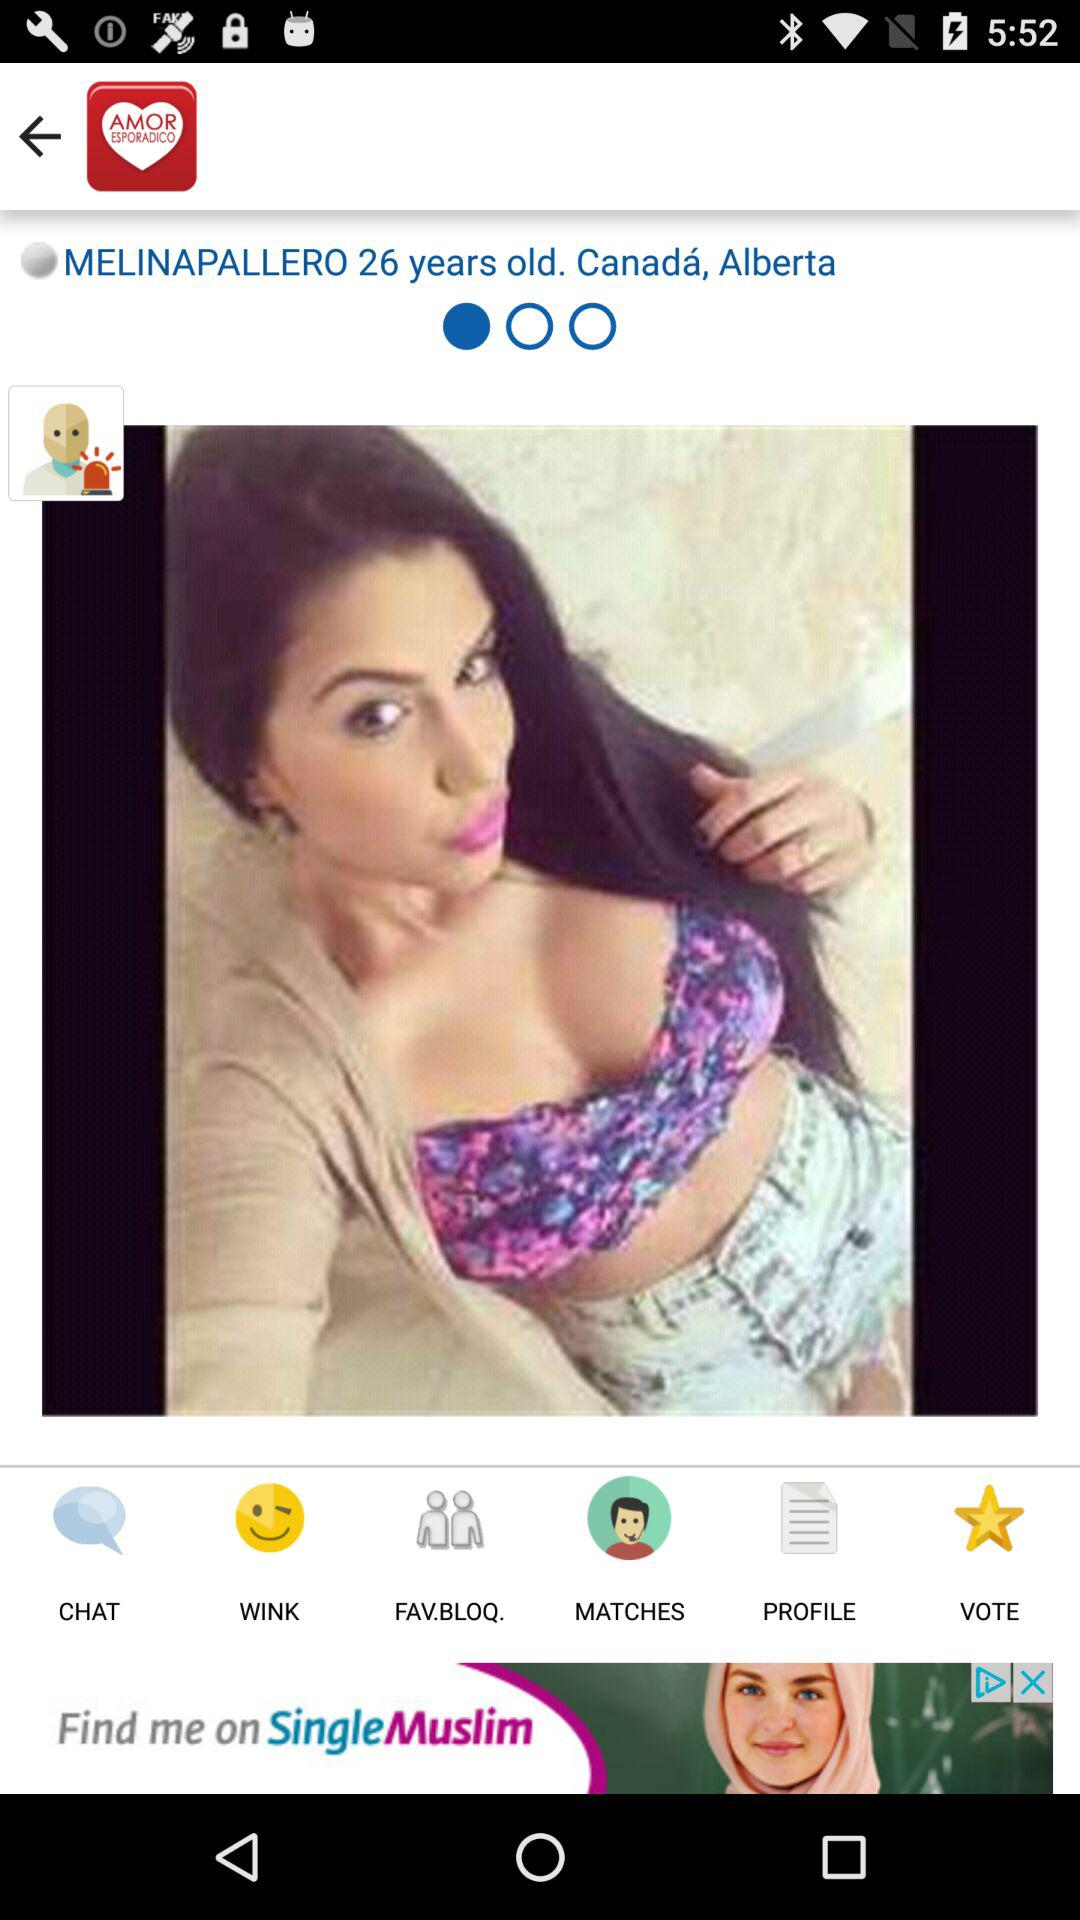What is the age of "MELINAPALLERO"? "MELINAPALLERO" is 26 years old. 